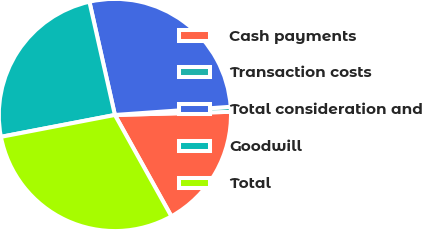<chart> <loc_0><loc_0><loc_500><loc_500><pie_chart><fcel>Cash payments<fcel>Transaction costs<fcel>Total consideration and<fcel>Goodwill<fcel>Total<nl><fcel>17.34%<fcel>0.69%<fcel>27.4%<fcel>24.49%<fcel>30.07%<nl></chart> 